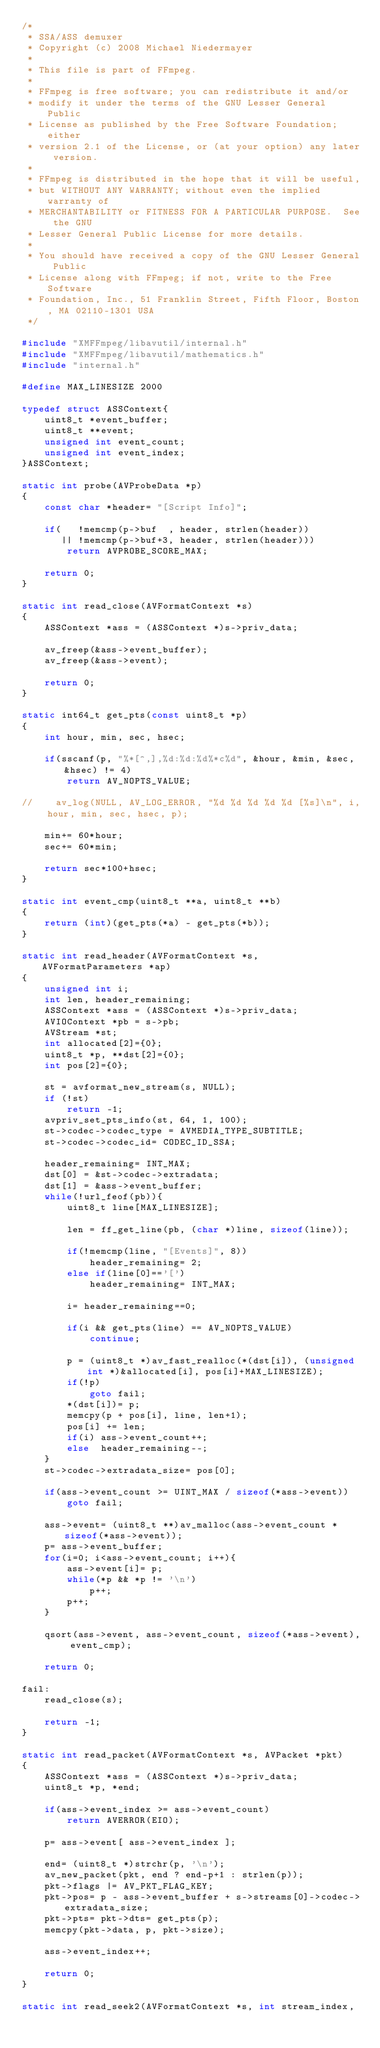<code> <loc_0><loc_0><loc_500><loc_500><_C++_>/*
 * SSA/ASS demuxer
 * Copyright (c) 2008 Michael Niedermayer
 *
 * This file is part of FFmpeg.
 *
 * FFmpeg is free software; you can redistribute it and/or
 * modify it under the terms of the GNU Lesser General Public
 * License as published by the Free Software Foundation; either
 * version 2.1 of the License, or (at your option) any later version.
 *
 * FFmpeg is distributed in the hope that it will be useful,
 * but WITHOUT ANY WARRANTY; without even the implied warranty of
 * MERCHANTABILITY or FITNESS FOR A PARTICULAR PURPOSE.  See the GNU
 * Lesser General Public License for more details.
 *
 * You should have received a copy of the GNU Lesser General Public
 * License along with FFmpeg; if not, write to the Free Software
 * Foundation, Inc., 51 Franklin Street, Fifth Floor, Boston, MA 02110-1301 USA
 */

#include "XMFFmpeg/libavutil/internal.h"
#include "XMFFmpeg/libavutil/mathematics.h"
#include "internal.h"

#define MAX_LINESIZE 2000

typedef struct ASSContext{
    uint8_t *event_buffer;
    uint8_t **event;
    unsigned int event_count;
    unsigned int event_index;
}ASSContext;

static int probe(AVProbeData *p)
{
    const char *header= "[Script Info]";

    if(   !memcmp(p->buf  , header, strlen(header))
       || !memcmp(p->buf+3, header, strlen(header)))
        return AVPROBE_SCORE_MAX;

    return 0;
}

static int read_close(AVFormatContext *s)
{
    ASSContext *ass = (ASSContext *)s->priv_data;

    av_freep(&ass->event_buffer);
    av_freep(&ass->event);

    return 0;
}

static int64_t get_pts(const uint8_t *p)
{
    int hour, min, sec, hsec;

    if(sscanf(p, "%*[^,],%d:%d:%d%*c%d", &hour, &min, &sec, &hsec) != 4)
        return AV_NOPTS_VALUE;

//    av_log(NULL, AV_LOG_ERROR, "%d %d %d %d %d [%s]\n", i, hour, min, sec, hsec, p);

    min+= 60*hour;
    sec+= 60*min;

    return sec*100+hsec;
}

static int event_cmp(uint8_t **a, uint8_t **b)
{
    return (int)(get_pts(*a) - get_pts(*b));
}

static int read_header(AVFormatContext *s, AVFormatParameters *ap)
{
    unsigned int i;
	int len, header_remaining;
    ASSContext *ass = (ASSContext *)s->priv_data;
    AVIOContext *pb = s->pb;
    AVStream *st;
    int allocated[2]={0};
    uint8_t *p, **dst[2]={0};
    int pos[2]={0};

    st = avformat_new_stream(s, NULL);
    if (!st)
        return -1;
    avpriv_set_pts_info(st, 64, 1, 100);
    st->codec->codec_type = AVMEDIA_TYPE_SUBTITLE;
    st->codec->codec_id= CODEC_ID_SSA;

    header_remaining= INT_MAX;
    dst[0] = &st->codec->extradata;
    dst[1] = &ass->event_buffer;
    while(!url_feof(pb)){
        uint8_t line[MAX_LINESIZE];

        len = ff_get_line(pb, (char *)line, sizeof(line));

        if(!memcmp(line, "[Events]", 8))
            header_remaining= 2;
        else if(line[0]=='[')
            header_remaining= INT_MAX;

        i= header_remaining==0;

        if(i && get_pts(line) == AV_NOPTS_VALUE)
            continue;

        p = (uint8_t *)av_fast_realloc(*(dst[i]), (unsigned int *)&allocated[i], pos[i]+MAX_LINESIZE);
        if(!p)
            goto fail;
        *(dst[i])= p;
        memcpy(p + pos[i], line, len+1);
        pos[i] += len;
        if(i) ass->event_count++;
        else  header_remaining--;
    }
    st->codec->extradata_size= pos[0];

    if(ass->event_count >= UINT_MAX / sizeof(*ass->event))
        goto fail;

    ass->event= (uint8_t **)av_malloc(ass->event_count * sizeof(*ass->event));
    p= ass->event_buffer;
    for(i=0; i<ass->event_count; i++){
        ass->event[i]= p;
        while(*p && *p != '\n')
            p++;
        p++;
    }

    qsort(ass->event, ass->event_count, sizeof(*ass->event), event_cmp);

    return 0;

fail:
    read_close(s);

    return -1;
}

static int read_packet(AVFormatContext *s, AVPacket *pkt)
{
    ASSContext *ass = (ASSContext *)s->priv_data;
    uint8_t *p, *end;

    if(ass->event_index >= ass->event_count)
        return AVERROR(EIO);

    p= ass->event[ ass->event_index ];

    end= (uint8_t *)strchr(p, '\n');
    av_new_packet(pkt, end ? end-p+1 : strlen(p));
    pkt->flags |= AV_PKT_FLAG_KEY;
    pkt->pos= p - ass->event_buffer + s->streams[0]->codec->extradata_size;
    pkt->pts= pkt->dts= get_pts(p);
    memcpy(pkt->data, p, pkt->size);

    ass->event_index++;

    return 0;
}

static int read_seek2(AVFormatContext *s, int stream_index,</code> 